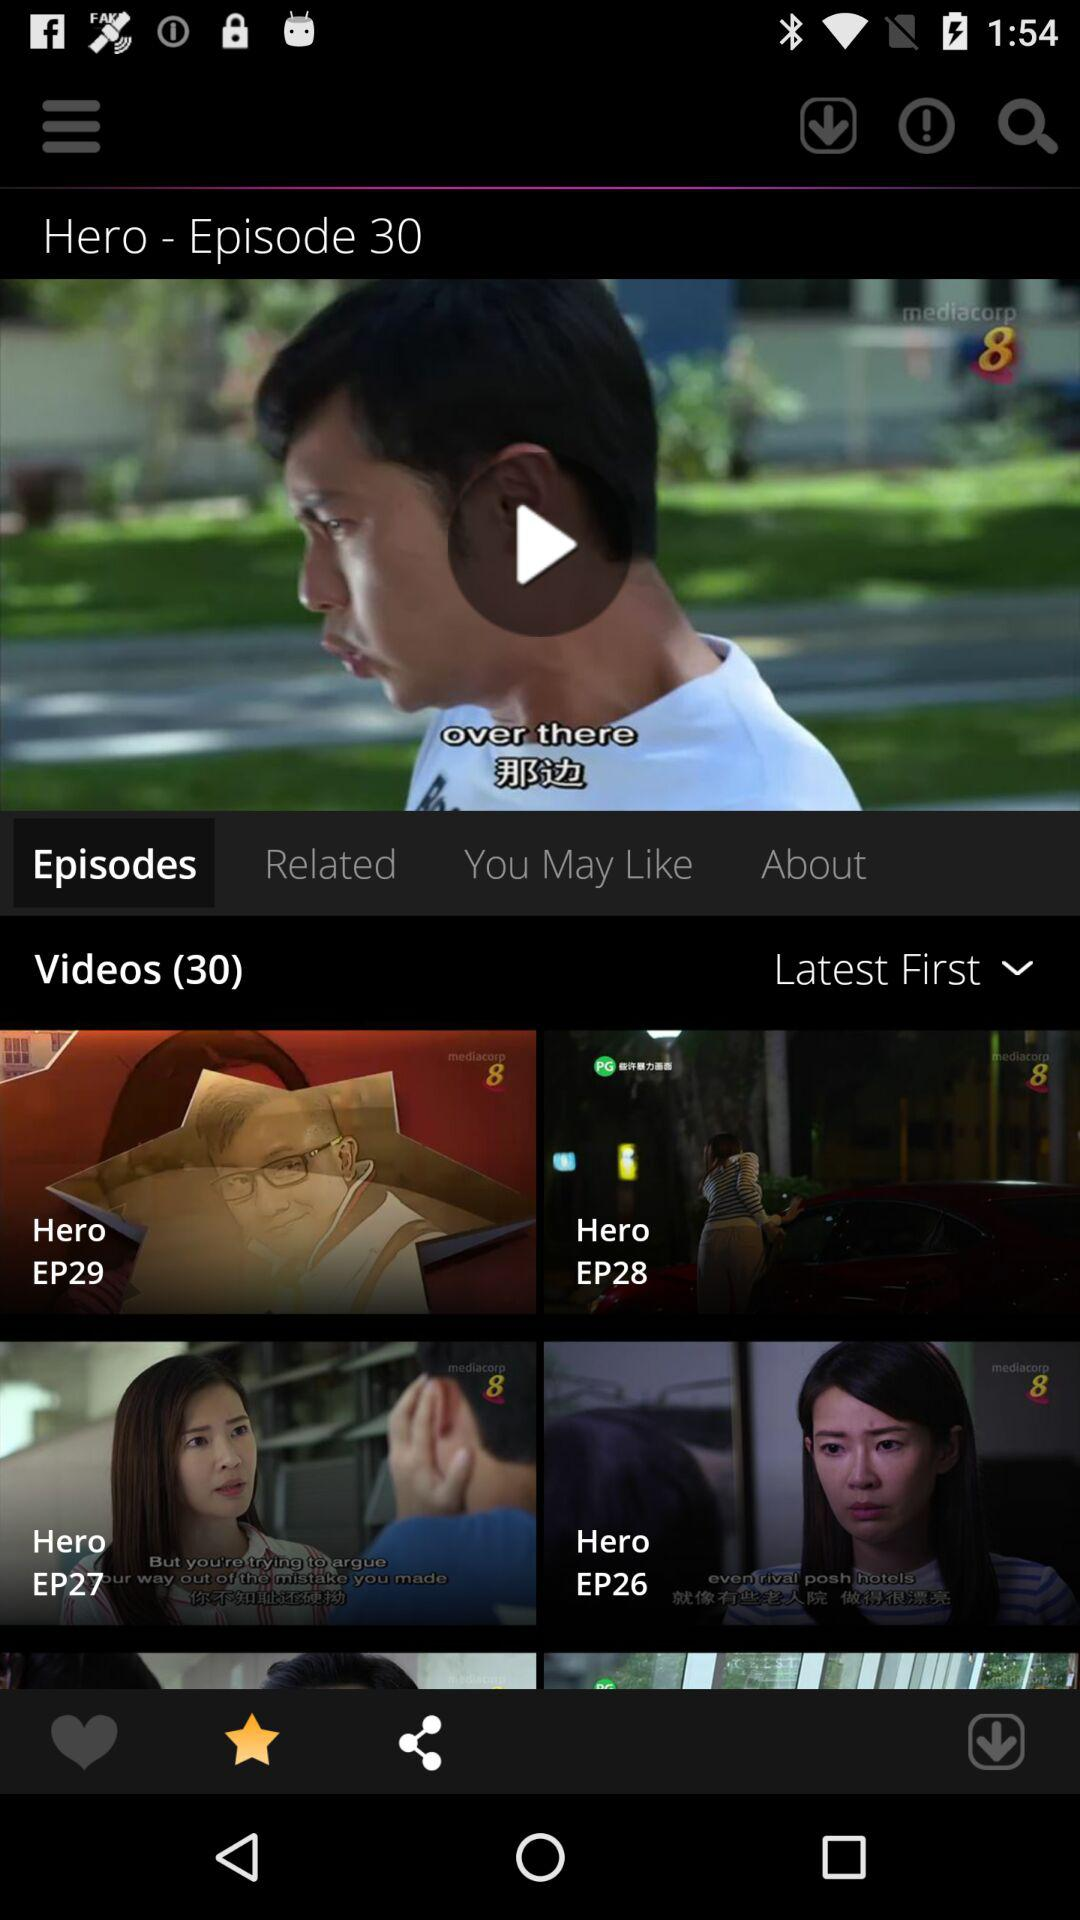How many seasons of "Hero" are there?
When the provided information is insufficient, respond with <no answer>. <no answer> 